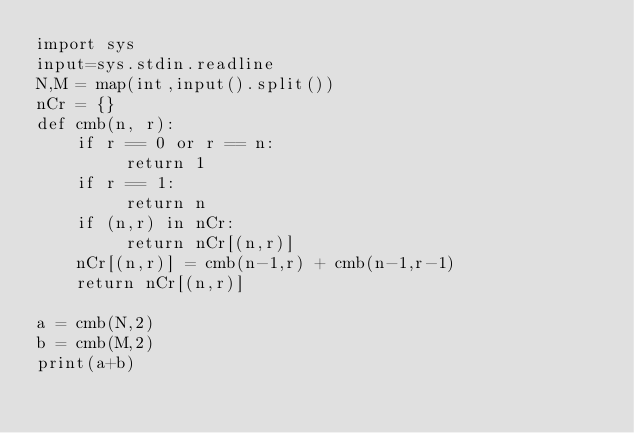<code> <loc_0><loc_0><loc_500><loc_500><_Python_>import sys
input=sys.stdin.readline
N,M = map(int,input().split())
nCr = {}
def cmb(n, r):
    if r == 0 or r == n:
         return 1
    if r == 1:
         return n
    if (n,r) in nCr:
         return nCr[(n,r)]
    nCr[(n,r)] = cmb(n-1,r) + cmb(n-1,r-1)
    return nCr[(n,r)]

a = cmb(N,2)
b = cmb(M,2)
print(a+b)</code> 